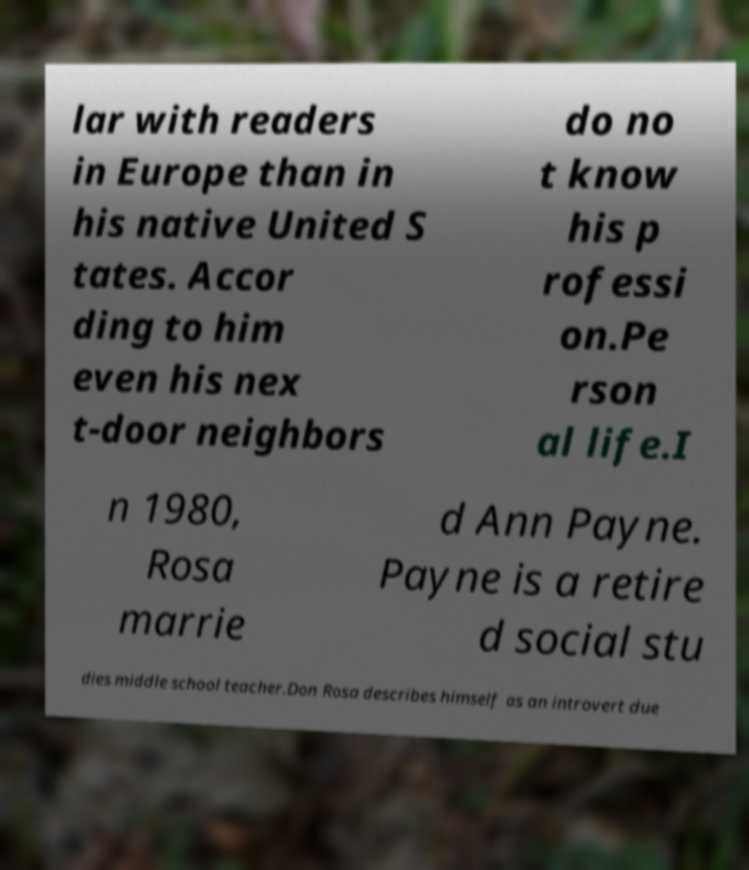Could you assist in decoding the text presented in this image and type it out clearly? lar with readers in Europe than in his native United S tates. Accor ding to him even his nex t-door neighbors do no t know his p rofessi on.Pe rson al life.I n 1980, Rosa marrie d Ann Payne. Payne is a retire d social stu dies middle school teacher.Don Rosa describes himself as an introvert due 